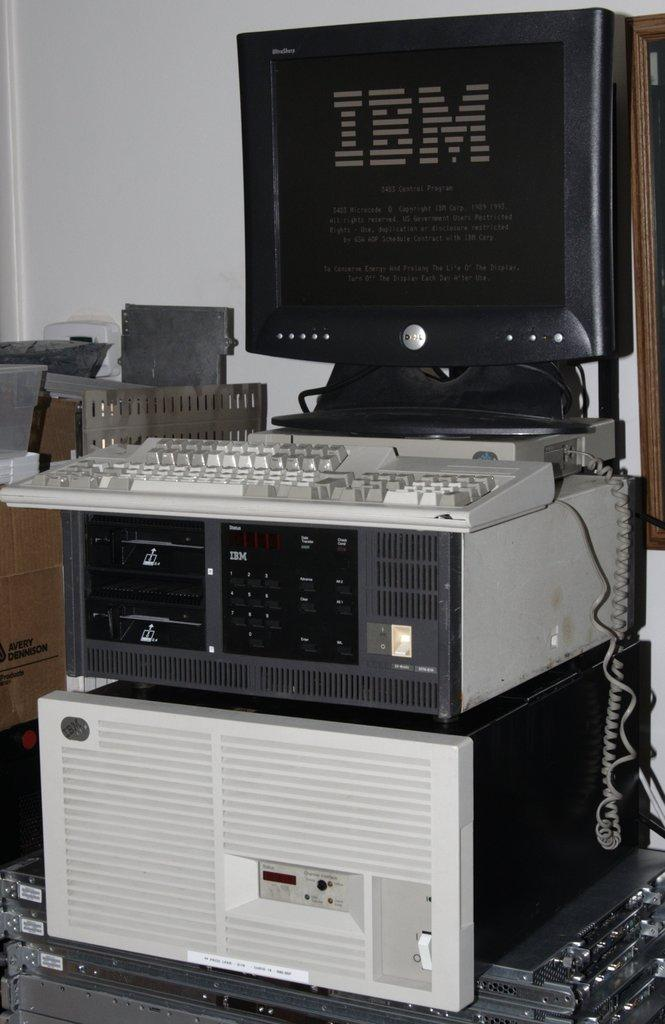<image>
Relay a brief, clear account of the picture shown. A Dell computer shows the words IBM on display 